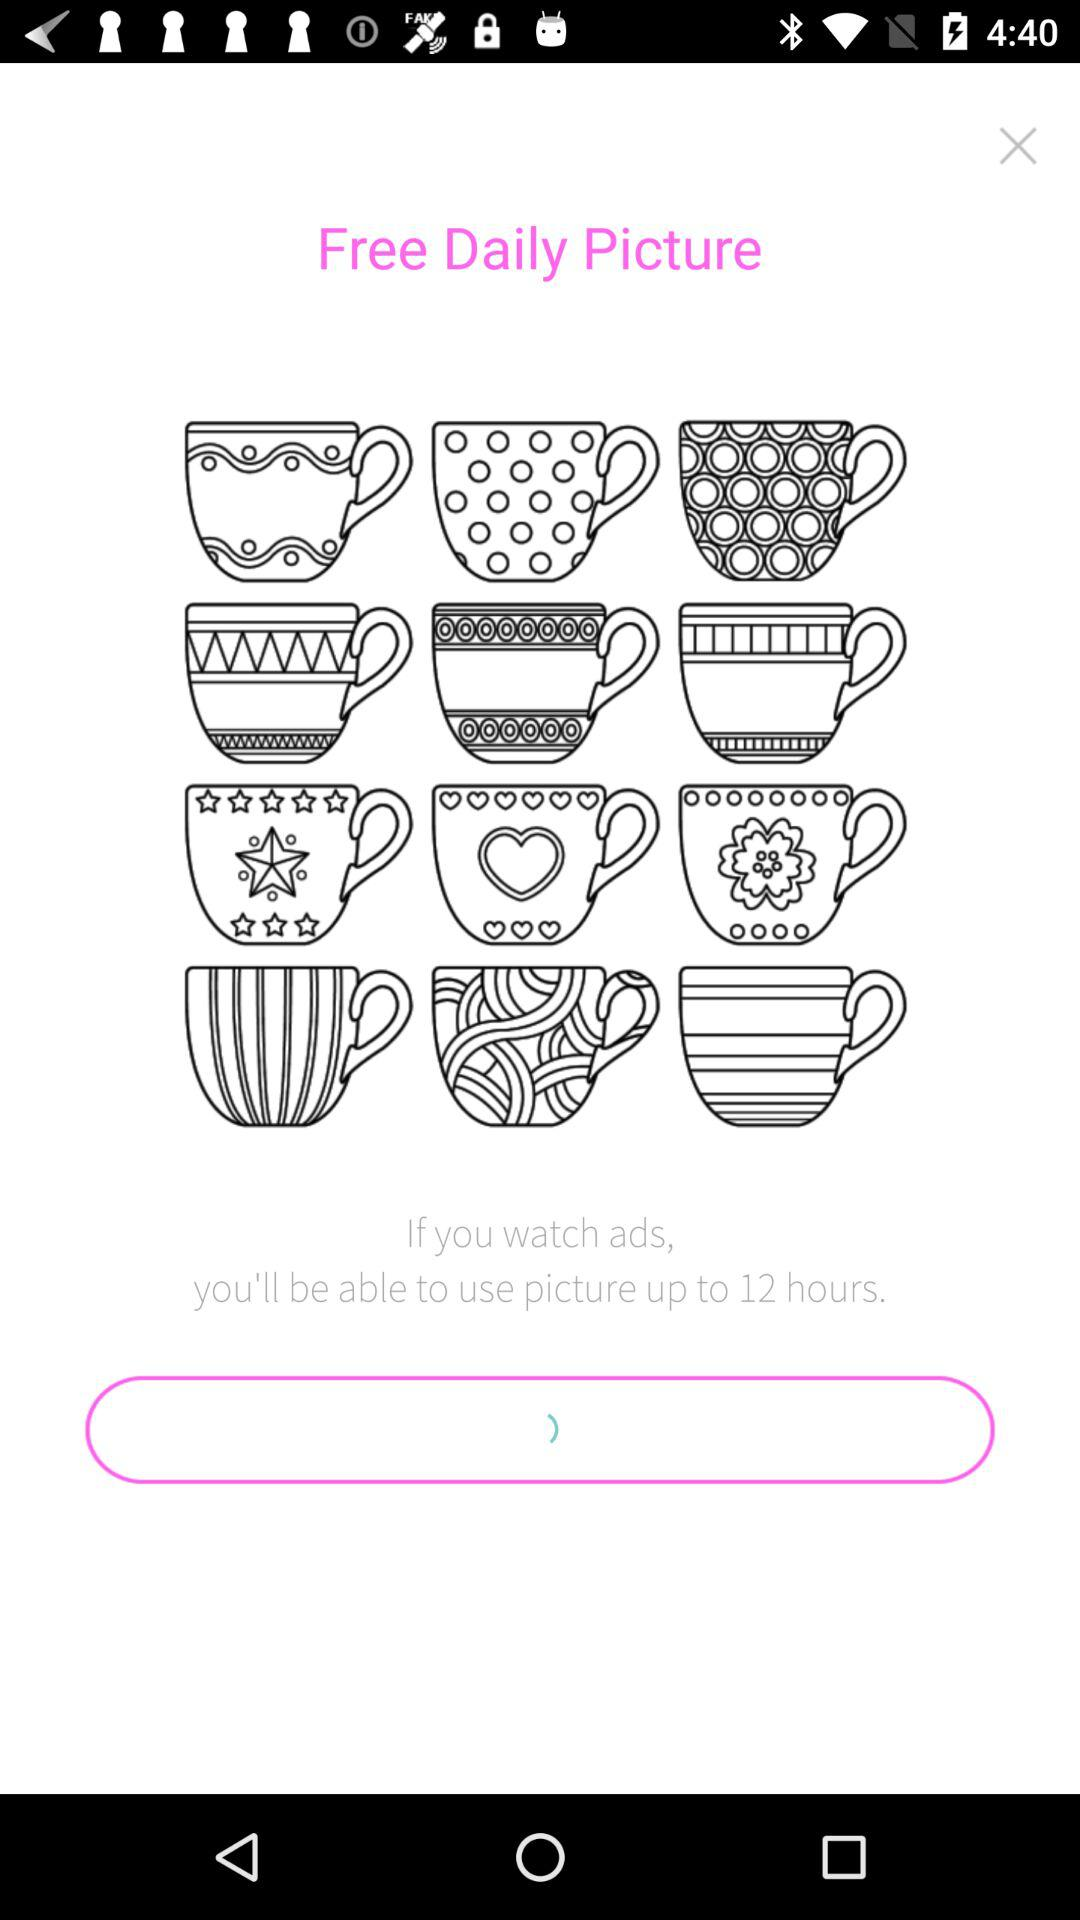How many hours longer can I use the picture if I watch ads?
Answer the question using a single word or phrase. 12 